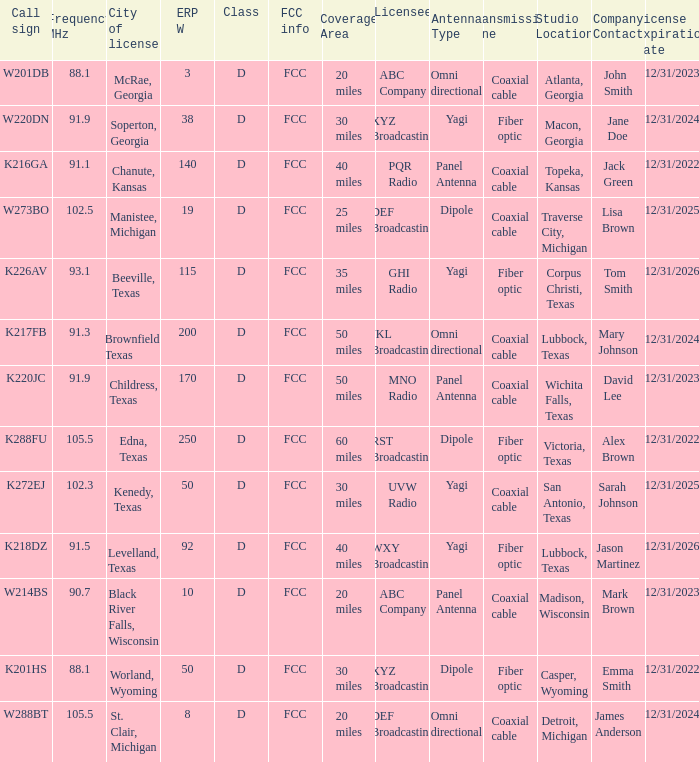What is Call Sign, when ERP W is greater than 50? K216GA, K226AV, K217FB, K220JC, K288FU, K218DZ. 